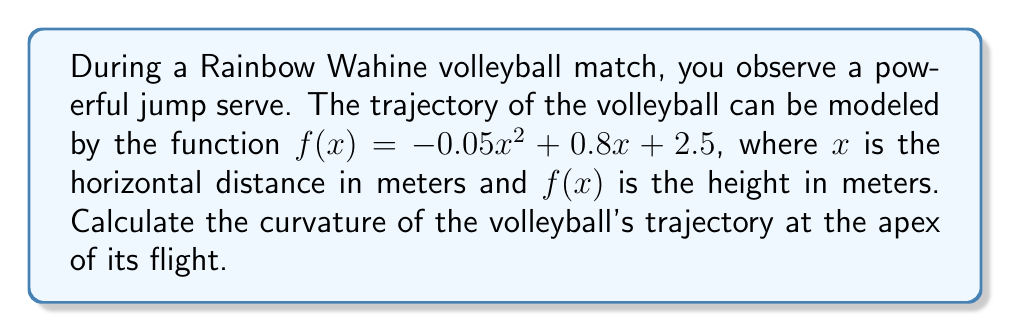Can you solve this math problem? To solve this problem, we'll follow these steps:

1) First, we need to find the x-coordinate of the apex. This occurs where $f'(x) = 0$.

   $f'(x) = -0.1x + 0.8$
   $0 = -0.1x + 0.8$
   $x = 8$ meters

2) The formula for curvature $\kappa$ at a point $(x,y)$ for a function $y = f(x)$ is:

   $$\kappa = \frac{|f''(x)|}{(1 + (f'(x))^2)^{3/2}}$$

3) We need to calculate $f'(x)$ and $f''(x)$:

   $f'(x) = -0.1x + 0.8$
   $f''(x) = -0.1$

4) At $x = 8$ (the apex):

   $f'(8) = -0.1(8) + 0.8 = 0$
   $f''(8) = -0.1$

5) Now we can substitute these values into the curvature formula:

   $$\kappa = \frac{|-0.1|}{(1 + (0)^2)^{3/2}} = \frac{0.1}{1} = 0.1$$

Therefore, the curvature of the volleyball's trajectory at the apex is 0.1 m^(-1).
Answer: $0.1$ m^(-1) 